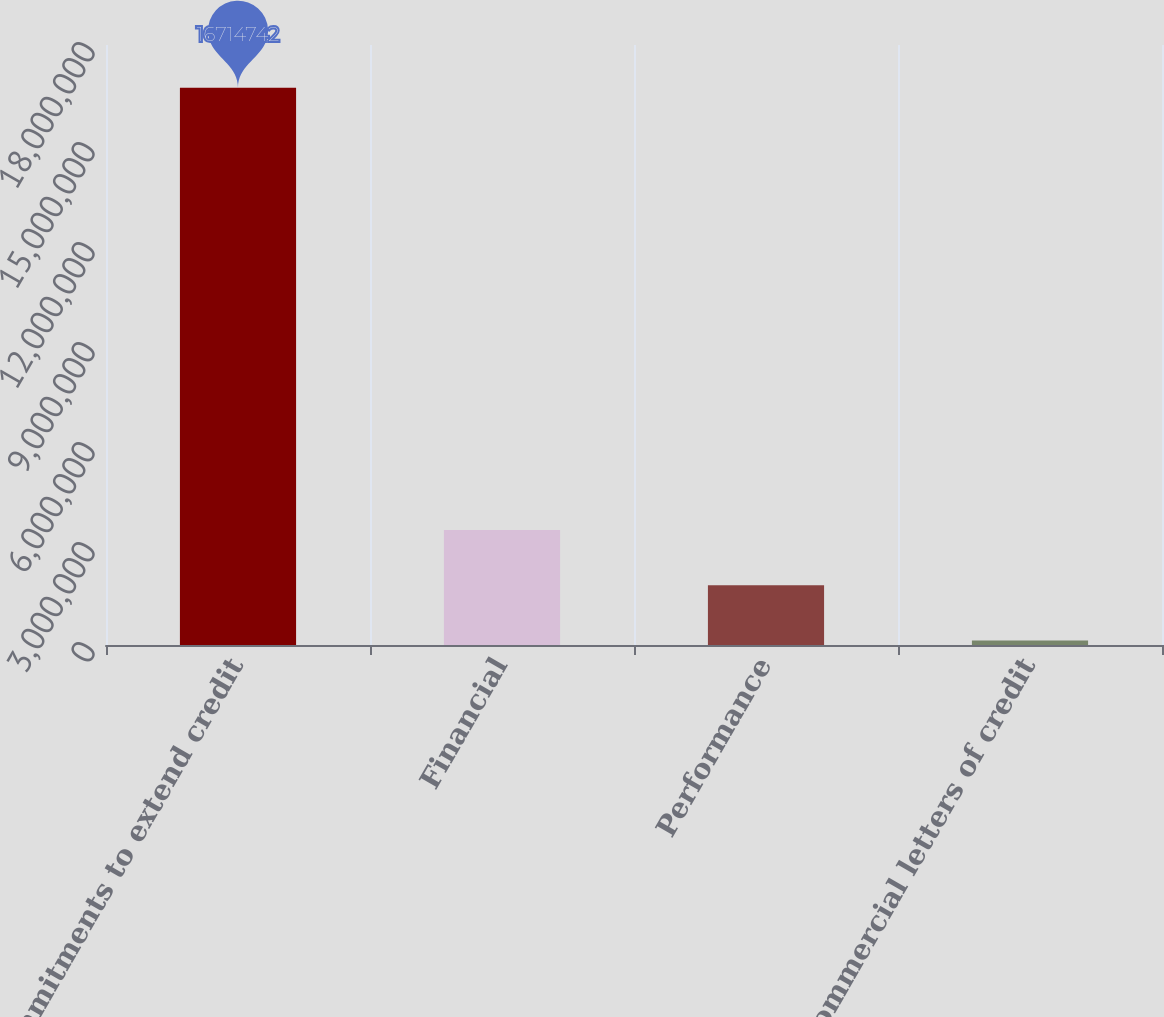<chart> <loc_0><loc_0><loc_500><loc_500><bar_chart><fcel>Commitments to extend credit<fcel>Financial<fcel>Performance<fcel>Commercial letters of credit<nl><fcel>1.67147e+07<fcel>3.44904e+06<fcel>1.79083e+06<fcel>132615<nl></chart> 